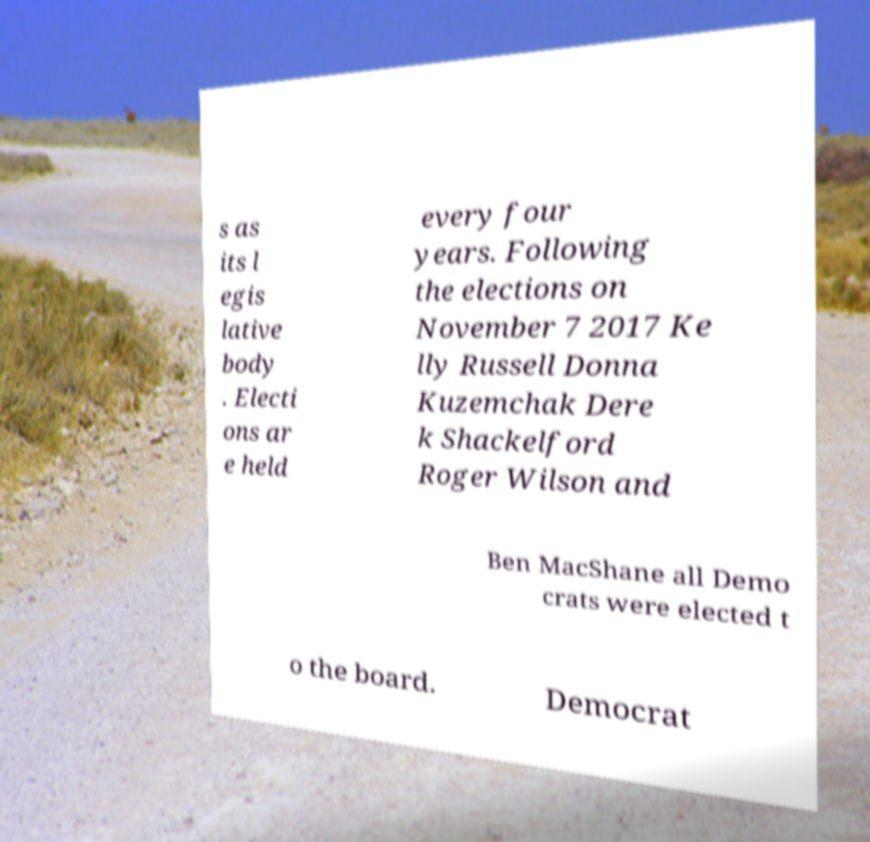For documentation purposes, I need the text within this image transcribed. Could you provide that? s as its l egis lative body . Electi ons ar e held every four years. Following the elections on November 7 2017 Ke lly Russell Donna Kuzemchak Dere k Shackelford Roger Wilson and Ben MacShane all Demo crats were elected t o the board. Democrat 